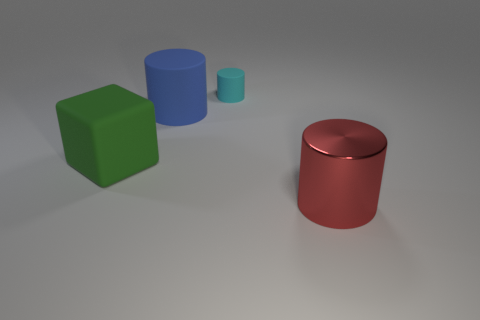Add 3 matte objects. How many objects exist? 7 Subtract all blocks. How many objects are left? 3 Subtract all big red metallic objects. Subtract all cylinders. How many objects are left? 0 Add 1 large green rubber things. How many large green rubber things are left? 2 Add 2 large brown shiny cylinders. How many large brown shiny cylinders exist? 2 Subtract 1 cyan cylinders. How many objects are left? 3 